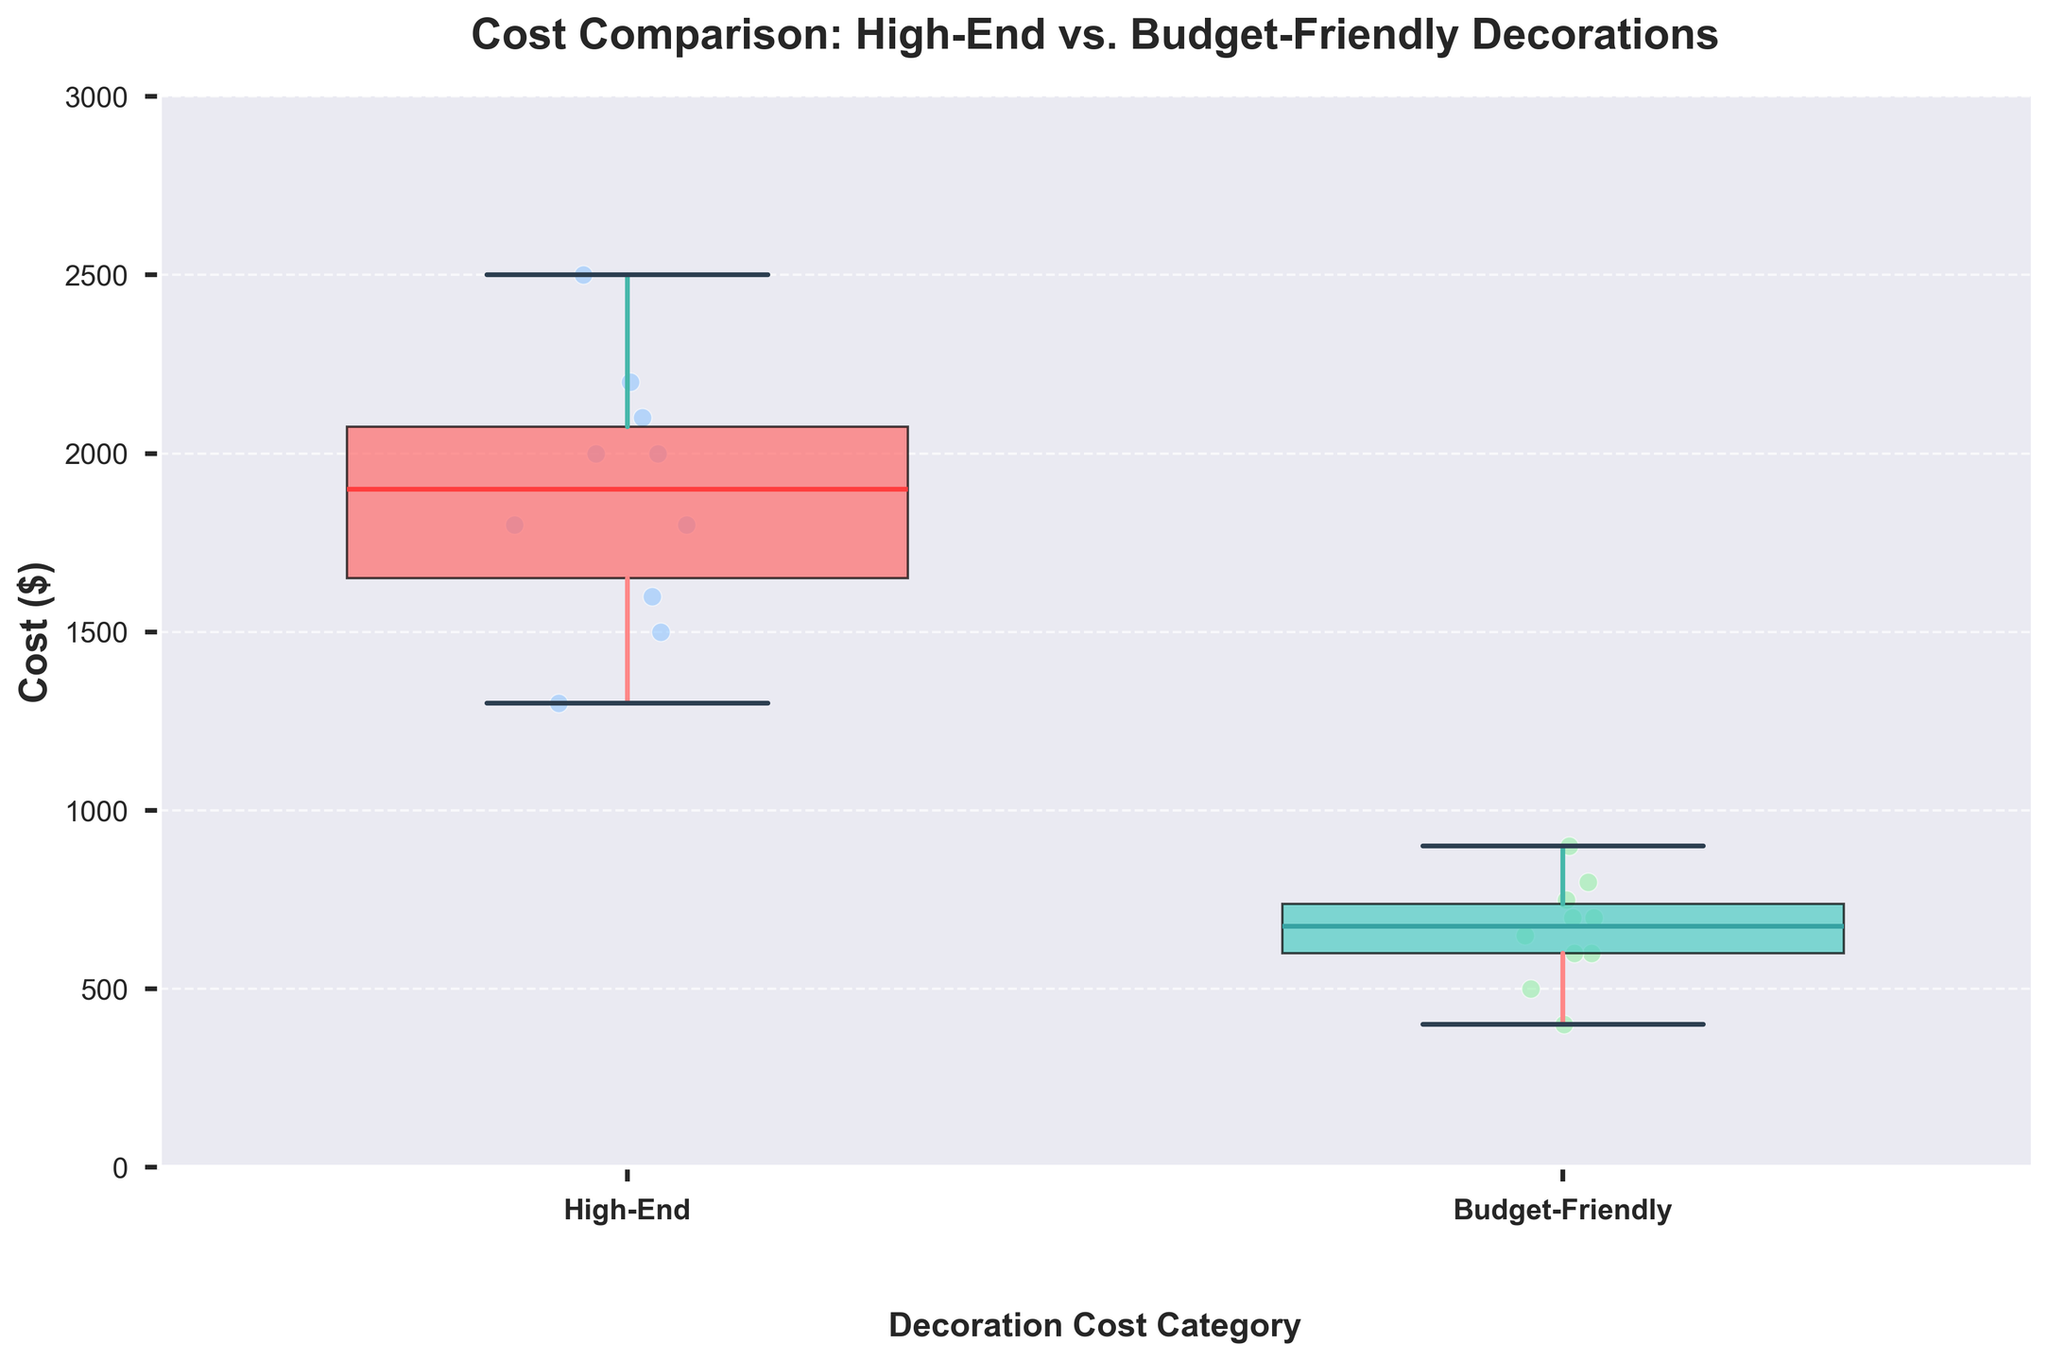How many decoration cost categories are compared in the plot? The plot has two boxplots representing different decoration cost categories. These are labeled "High-End" and "Budget-Friendly" on the x-axis.
Answer: Two Which cost category appears to have higher median values? The plot shows different medians for both categories. By observing the boxplots, the median line for the "High-End" category is higher than the one for the "Budget-Friendly" category.
Answer: High-End What is the approximate maximum cost for budget-friendly decorations? Referring to the whiskers of the "Budget-Friendly" boxplot, they appear to extend up to around 900. This suggests the maximum cost is near that value.
Answer: 900 Are there any outliers present in the "High-End" or "Budget-Friendly" categories? By looking for individual points outside the whisker range of each boxplot, we see several points within the box and whisker range. Hence, there are no outliers.
Answer: No What is the approximate range of costs for high-end decorations? The range is found by subtracting the value at the lower whisker from the value at the upper whisker of the "High-End" category boxplot. The range extends approximately from 1300 to 2500.
Answer: 1200 Do budget-friendly decorations have more variability in cost compared to high-end decorations? Variability is indicated by the interquartile range (IQR), the height of the box. Comparing the height of both boxes, the "High-End" box is taller, indicating greater variability in cost.
Answer: No Which cost category shows the higher minimum cost? The minimum cost is indicated by the lower whisker of each boxplot. The "High-End" category has a higher lower whisker value than the "Budget-Friendly" category.
Answer: High-End If an event designer has a budget limit of $1000, which category is more suitable? By comparing the median and range of each category, since "Budget-Friendly" decorations mostly fall below $1000, while "High-End" mostly exceeds it. Hence, "Budget-Friendly" is more suitable.
Answer: Budget-Friendly What is the main visual element used to differentiate between the cost categories? Each category is differentiated using different boxplot colors. "High-End" has one color, and "Budget-Friendly" has another distinct color.
Answer: Different Colors 